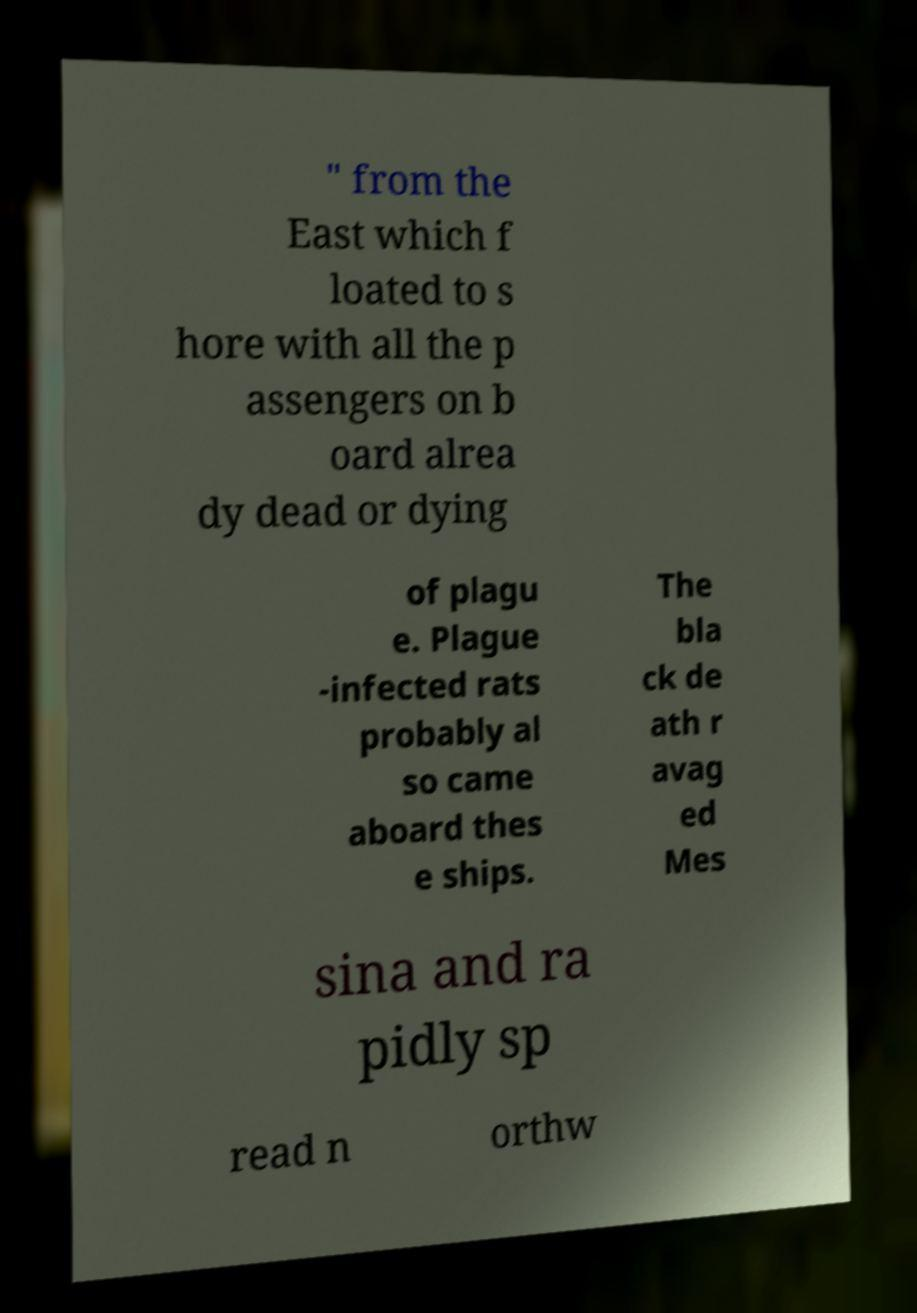Please read and relay the text visible in this image. What does it say? " from the East which f loated to s hore with all the p assengers on b oard alrea dy dead or dying of plagu e. Plague -infected rats probably al so came aboard thes e ships. The bla ck de ath r avag ed Mes sina and ra pidly sp read n orthw 